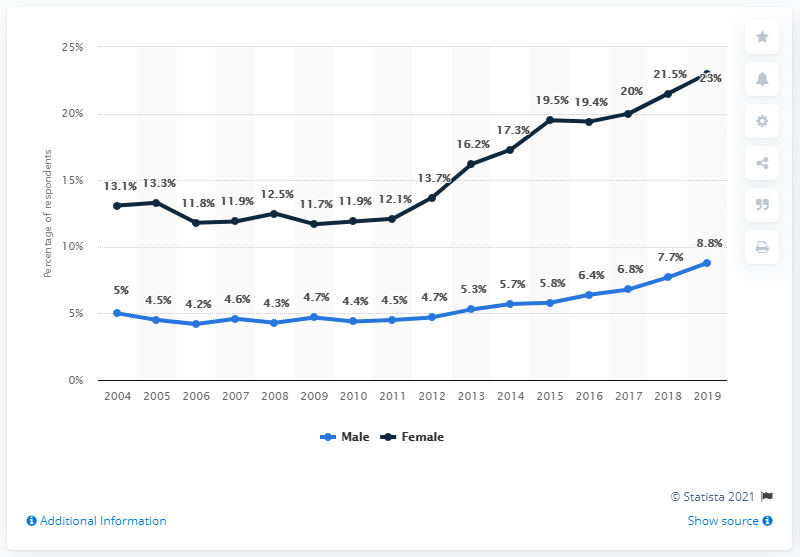Specify some key components in this picture. The combined total of males and females in 2015 was 25.3%. The highest value in the blue line chart is 8.8. 